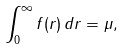Convert formula to latex. <formula><loc_0><loc_0><loc_500><loc_500>\int _ { 0 } ^ { \infty } f ( r ) \, d r = \mu ,</formula> 